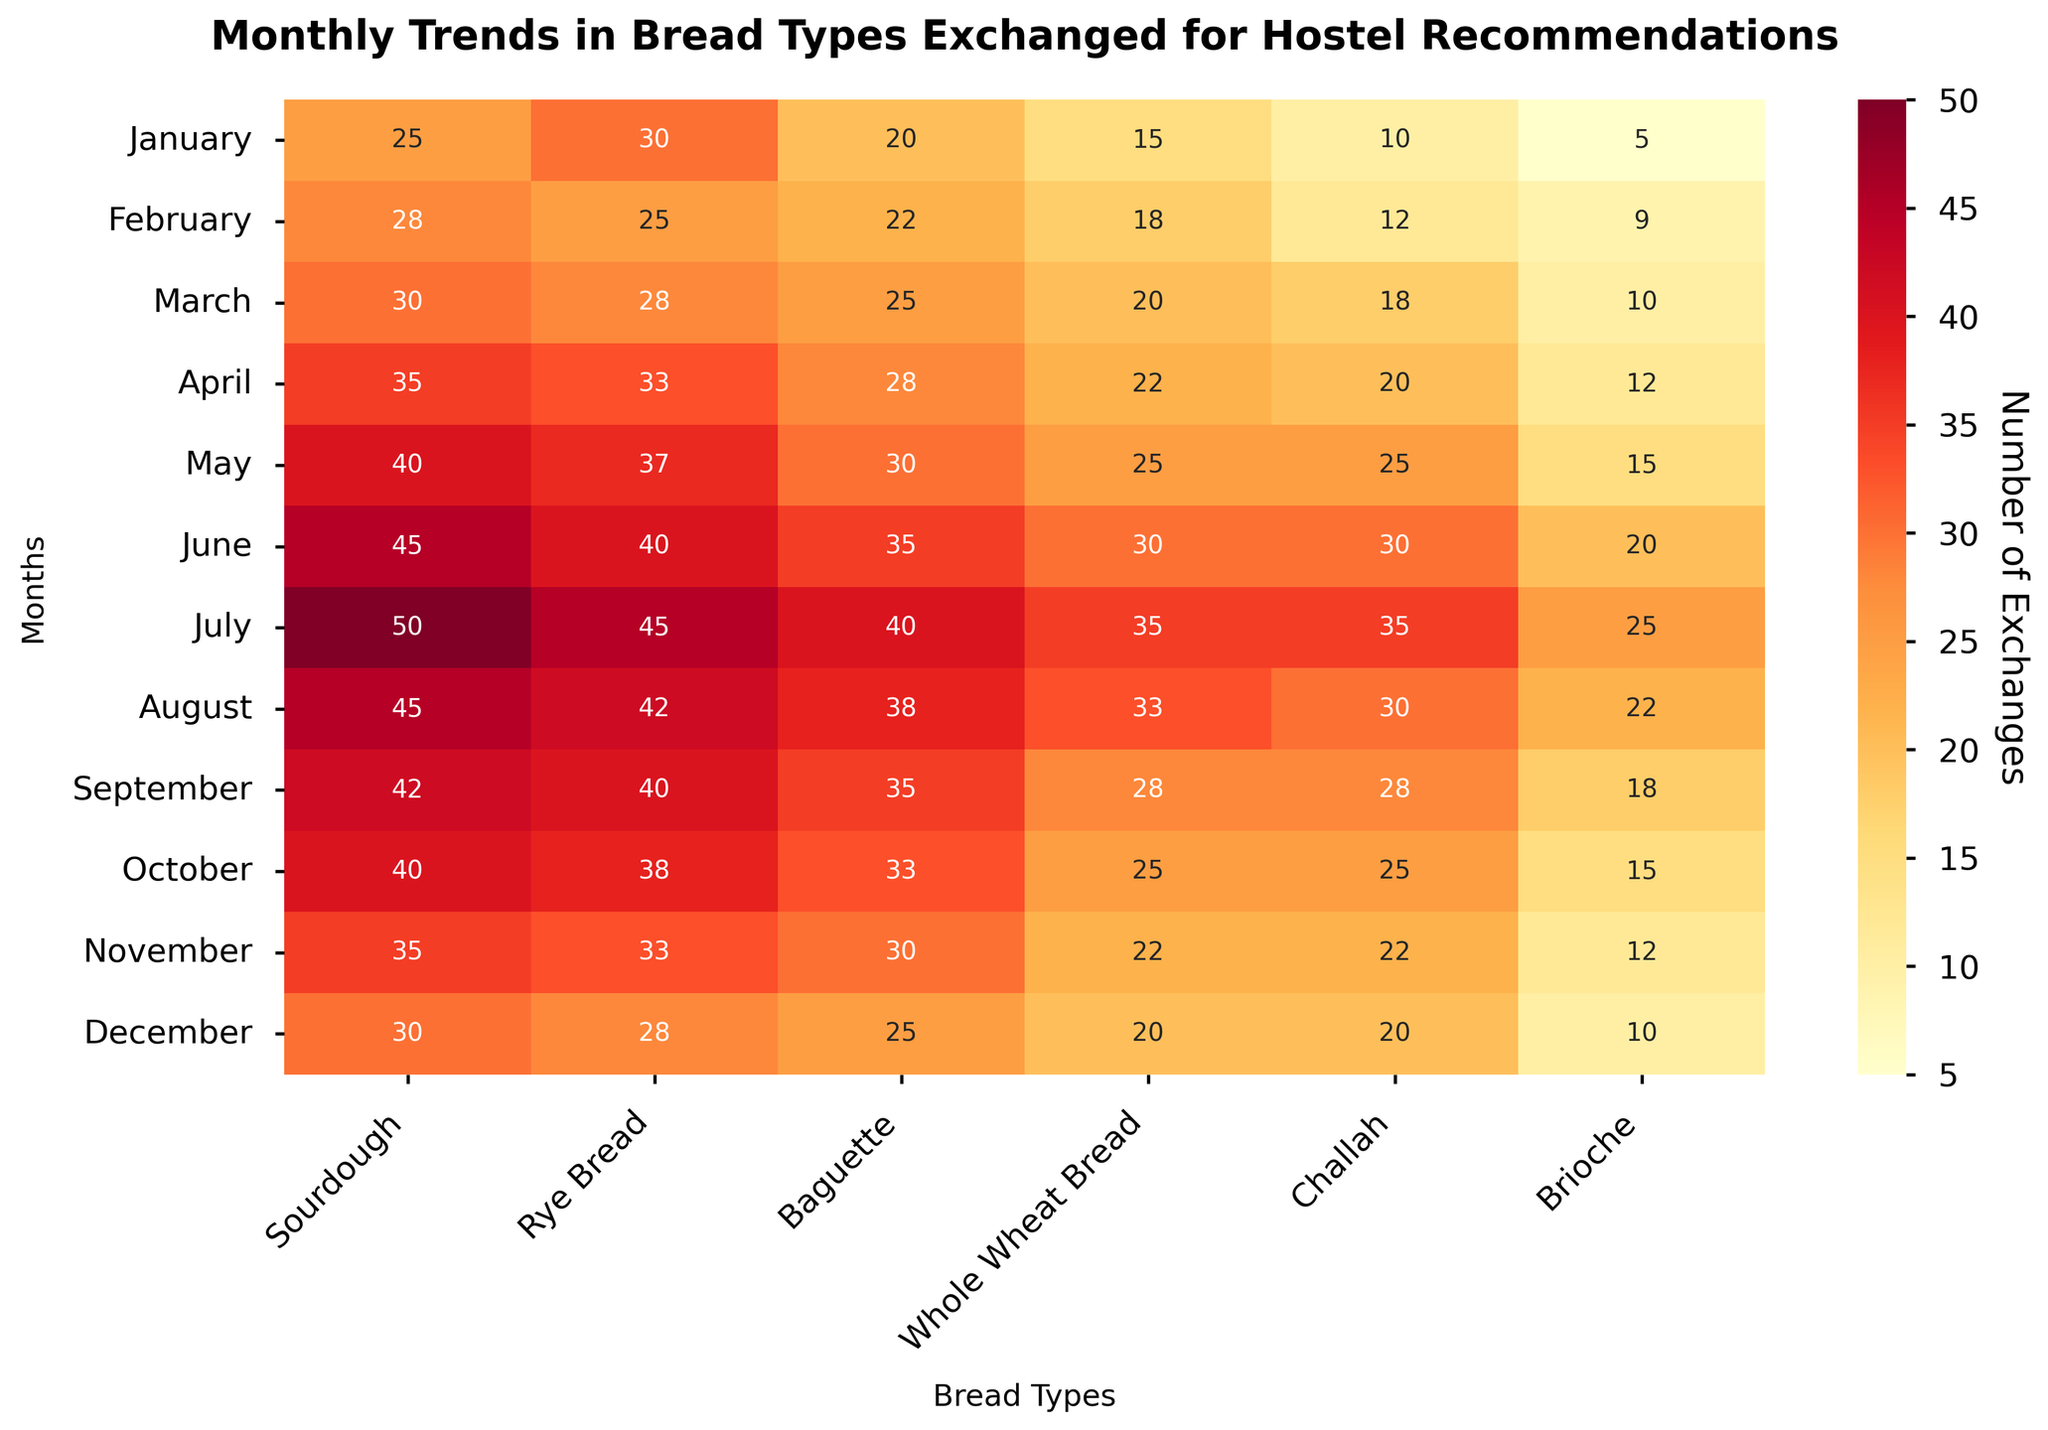What is the title of the heatmap? The title is usually displayed at the top of the figure. Here, it should be plainly visible and represent a summary of the data.
Answer: Monthly Trends in Bread Types Exchanged for Hostel Recommendations Which month has the highest number of Sourdough exchanges? Scan through the Sourdough column in the heatmap. The highest number will be apparent as the cell with the darkest color and highest annotation.
Answer: July What is the average number of Baguette exchanges across all months? Add all the values in the Baguette column then divide by the number of months (12). The values are 20, 22, 25, 28, 30, 35, 40, 38, 35, 33, 30, 25. Sum is 361. Divide by 12.
Answer: 30.1 Which bread type was exchanged the most in August? Identify the row corresponding to August and find the column with the highest value. The Baguette (38), Whole Wheat Bread (33), and Brioche (22) exchanges values help isolate the highest one.
Answer: Sourdough Which two months have the same number of exchanges for Brioche? Compare the values in the Brioche column for equality. November (12) and April (12) share equal values.
Answer: April and November How much more Rye Bread was exchanged in June compared to February? Subtract the number of exchanges in February from those in June (40 - 25).
Answer: 15 What is the median number of Whole Wheat Bread exchanges over the year? List the Whole Wheat Bread values in ascending order: 15, 18, 20, 22, 25, 25, 25, 28, 30, 33, 35. The median value is the middle number, which is the 6th value in the ordered list.
Answer: 25 In which month did the exchanges for Challah first reach 25? Starting from January, move through the Challah column until you find the first instance of 25 (May).
Answer: May Which month saw the least number of bread exchanges for any type, and what was it? Identify the smallest value in each row and compare across rows; January has the least exchange for Brioche.
Answer: January (Brioche) 